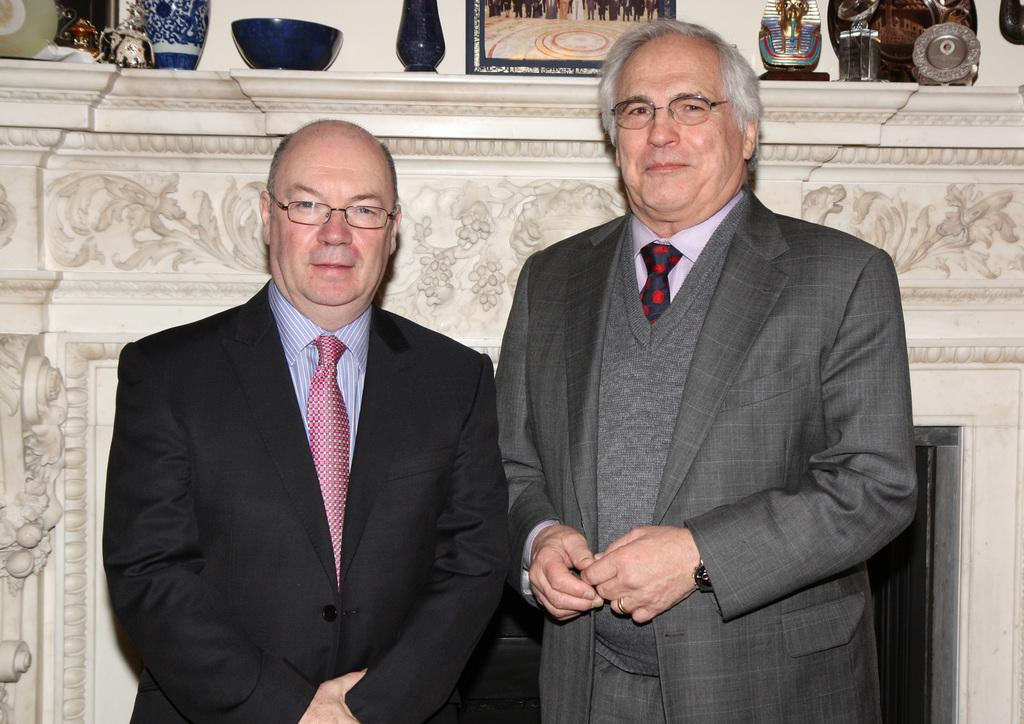What is the man in the image wearing? The man in the image is wearing a black coat. Can you describe the other man in the image? There is another man beside the man in the black coat. What is visible behind the two men? There is a wall behind the two men. What type of chalk is the man using to draw on the wall in the image? There is no chalk or drawing activity present in the image. 